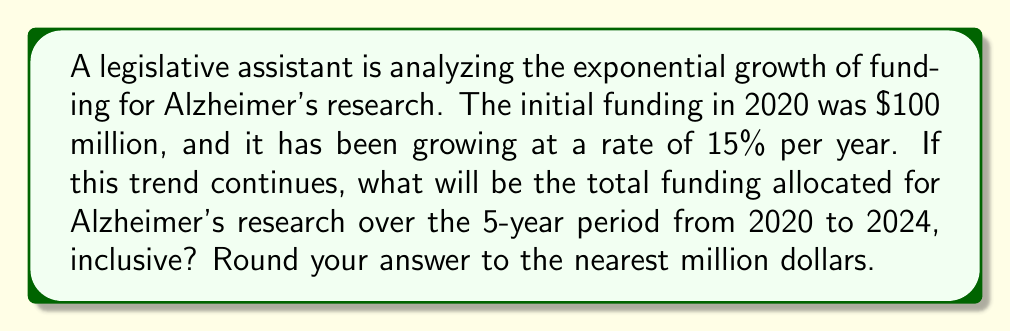Teach me how to tackle this problem. Let's approach this step-by-step:

1) The funding follows an exponential growth model: $A(t) = A_0(1+r)^t$
   Where $A_0$ is the initial amount, $r$ is the growth rate, and $t$ is the time in years.

2) Given:
   $A_0 = 100$ million
   $r = 15\% = 0.15$
   We need to calculate funding for years 0 to 4 (2020 to 2024)

3) Calculate funding for each year:
   2020 (t=0): $A(0) = 100(1.15)^0 = 100$ million
   2021 (t=1): $A(1) = 100(1.15)^1 = 115$ million
   2022 (t=2): $A(2) = 100(1.15)^2 = 132.25$ million
   2023 (t=3): $A(3) = 100(1.15)^3 = 152.09$ million
   2024 (t=4): $A(4) = 100(1.15)^4 = 174.90$ million

4) Sum up all years:
   $\text{Total} = 100 + 115 + 132.25 + 152.09 + 174.90 = 674.24$ million

5) Rounding to the nearest million:
   $674.24$ million rounds to $674$ million
Answer: $674 million 